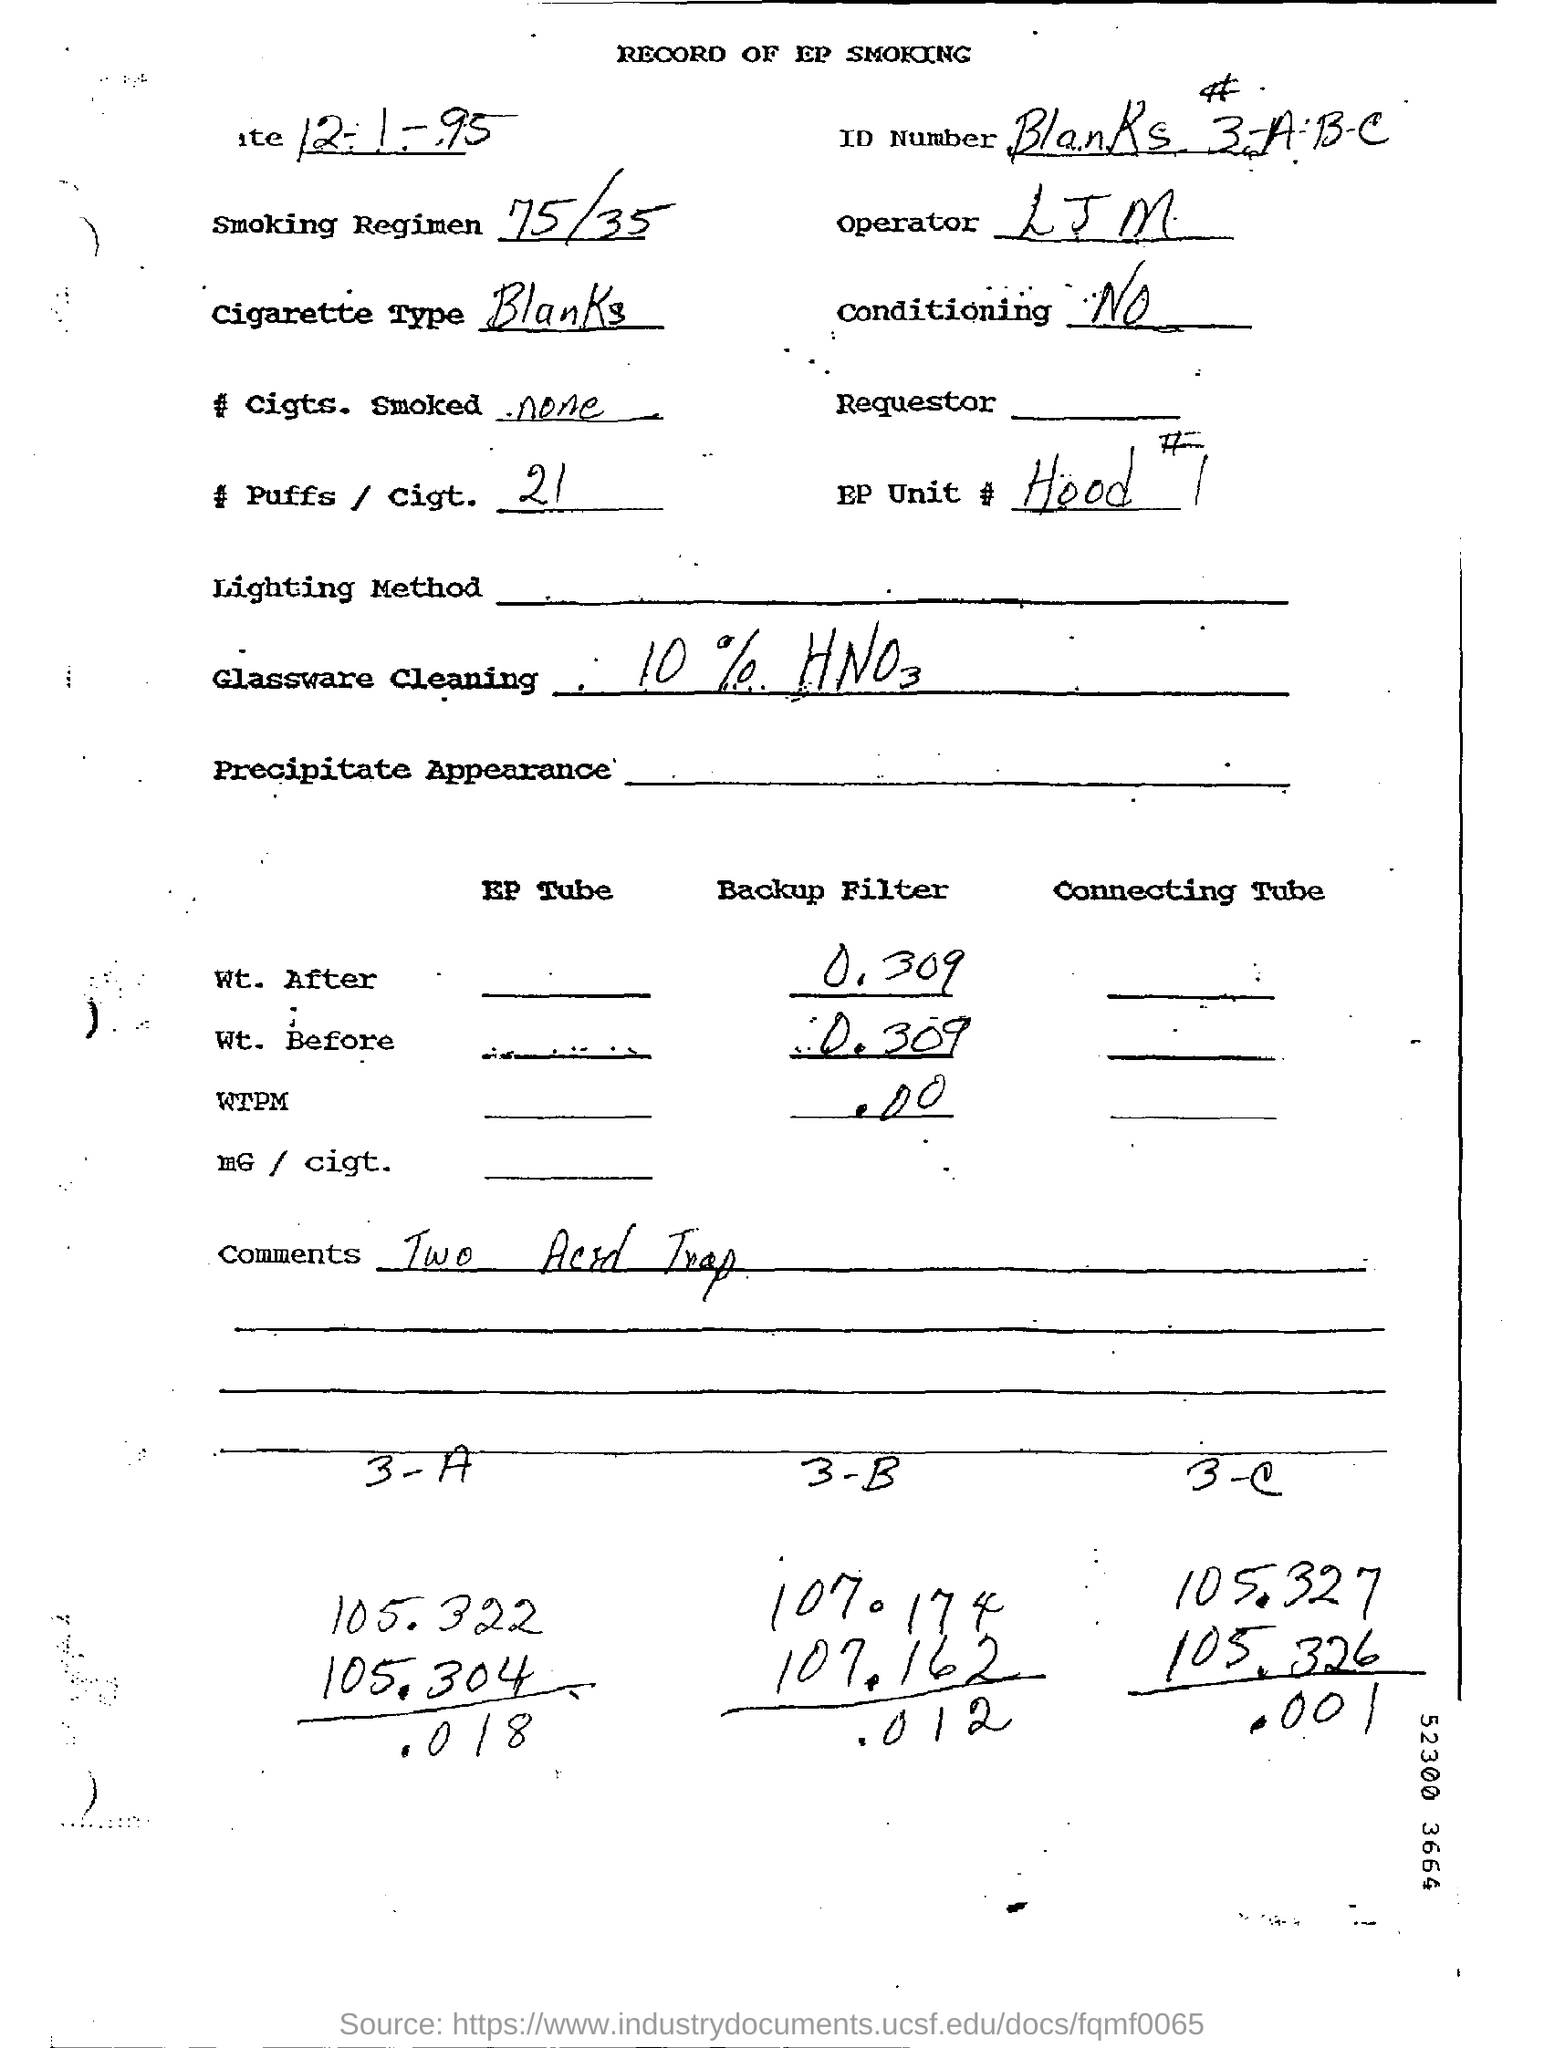List a handful of essential elements in this visual. The backup filter weight after a decimal value of 0.309 is [object of study]. The number of puffs per cigarette is 21. The comment written is "What is the comment written ? Two Acid Trap.. 